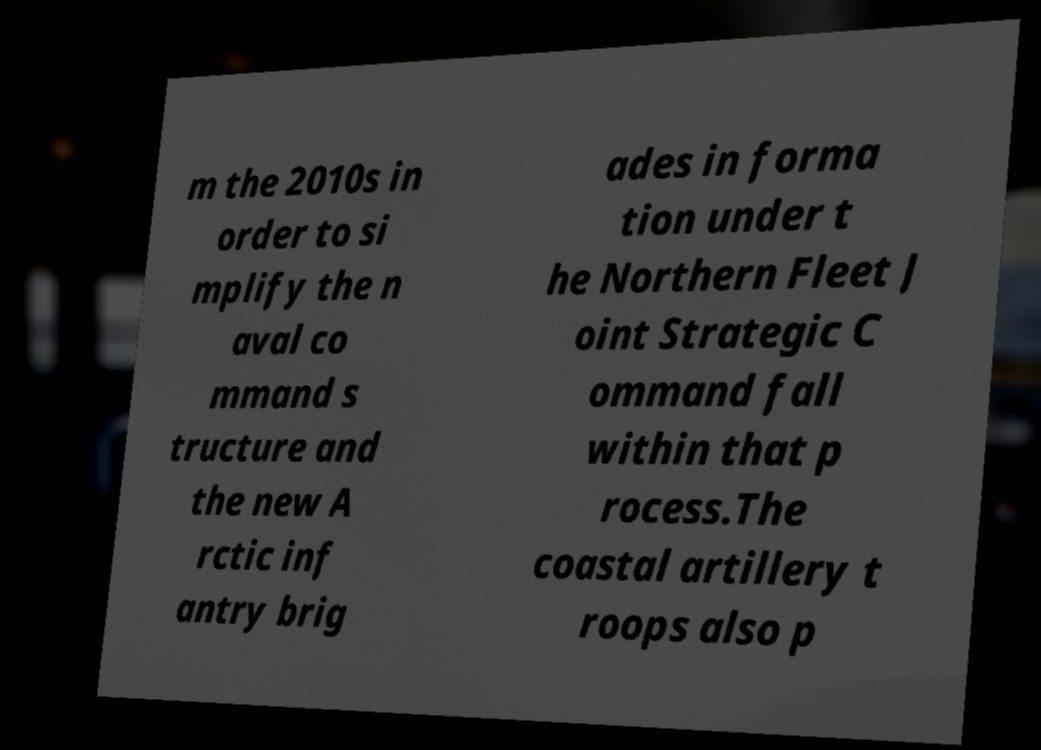Please identify and transcribe the text found in this image. m the 2010s in order to si mplify the n aval co mmand s tructure and the new A rctic inf antry brig ades in forma tion under t he Northern Fleet J oint Strategic C ommand fall within that p rocess.The coastal artillery t roops also p 